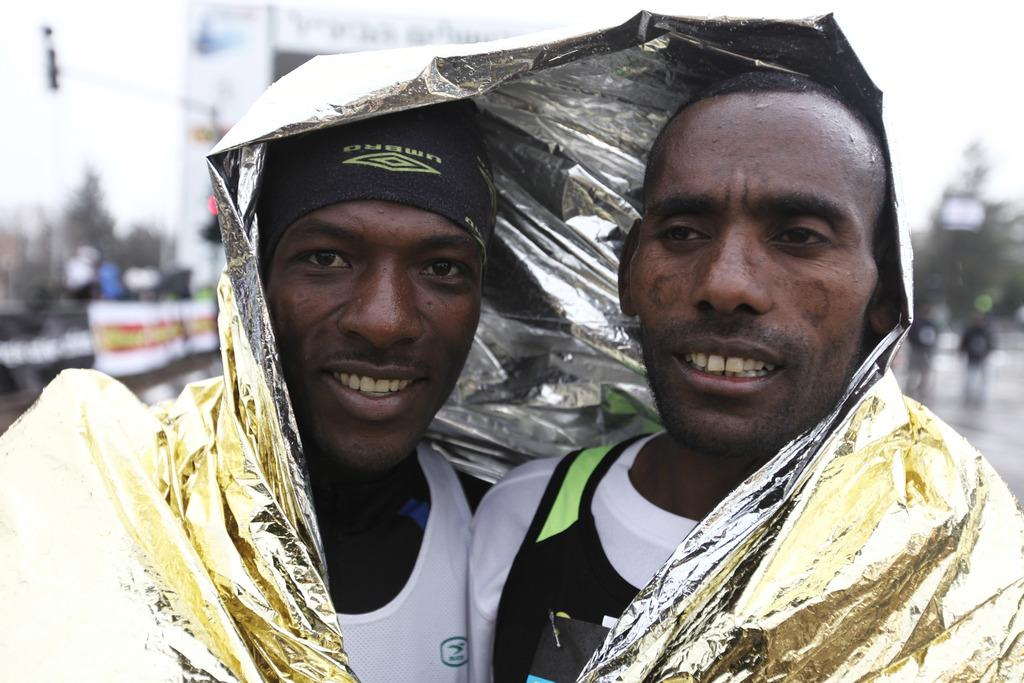What are the two people doing in the image? The two people are covered with a cover. Where are the people located in the image? The people are on the road. What can be seen in the background of the image? There are trees and a building in the image. What is present on the building in the image? There is a poster on the building. What is visible in the sky in the image? The sky is visible in the image. Can you see a monkey playing with a basin in the image? No, there is no monkey or basin present in the image. What type of pan is being used by the people in the image? There is no pan visible in the image; the two people are covered with a cover. 